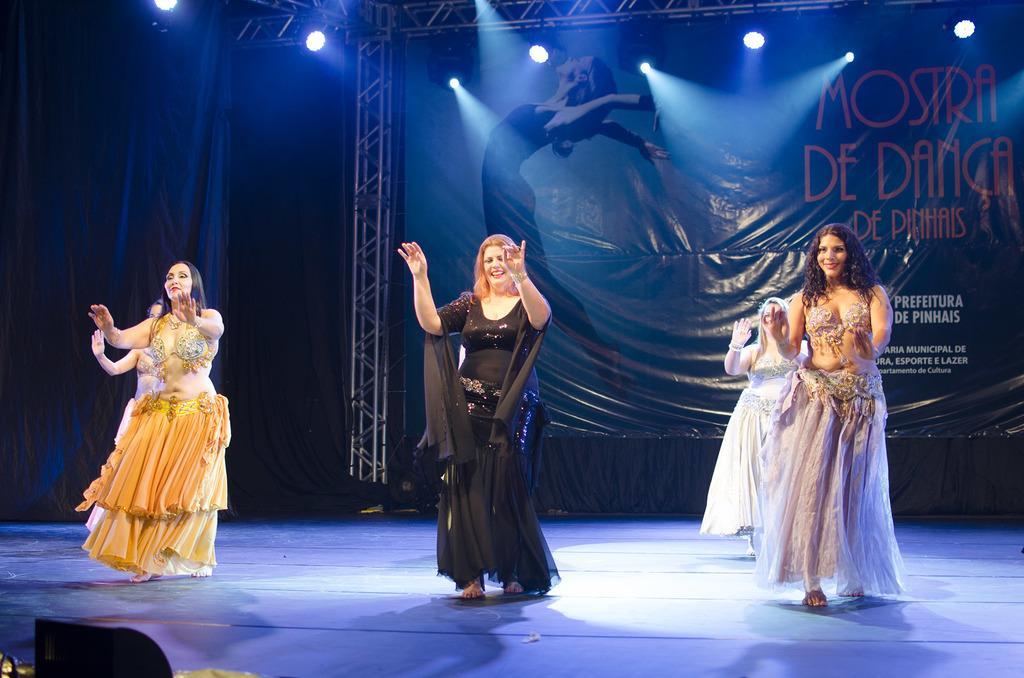Can you describe this image briefly? In the picture I can see a few women dancing on the floor and there is a pretty smile on their faces. In the background, I can see the hoarding. In the hoarding I can see a woman dancing and there is text on the right side. I can see the lighting arrangement on the metal scaffolding structure. I can see a curtain on the left side. 